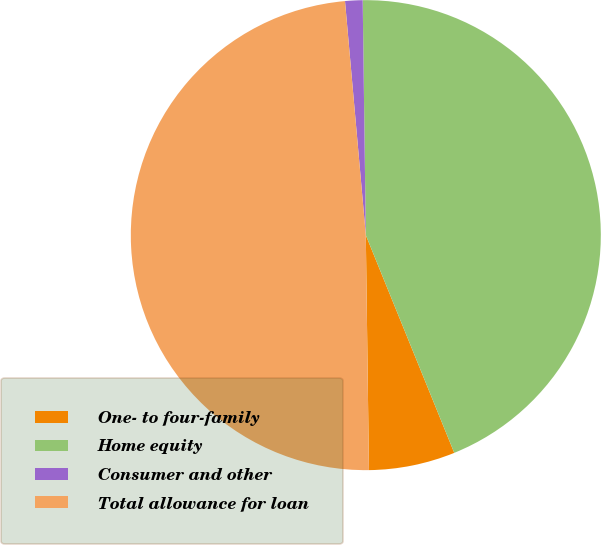Convert chart to OTSL. <chart><loc_0><loc_0><loc_500><loc_500><pie_chart><fcel>One- to four-family<fcel>Home equity<fcel>Consumer and other<fcel>Total allowance for loan<nl><fcel>5.93%<fcel>44.07%<fcel>1.2%<fcel>48.8%<nl></chart> 